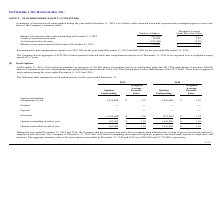According to Network 1 Technologies's financial document, Which note does the stockholders equity information belong to? According to the financial document, NOTE F. The relevant text states: "NOTE F – STOCKHOLDERS’ EQUITY (CONTINUED)..." Also, What does each restricted stock unit represent? each restricted stock unit represents the contingent right to receive one share of the Company’s common stock. The document states: "g the year ended December 31, 2019 is as follows (each restricted stock unit represents the contingent right to receive one share of the Company’s com..." Also, How many years are the unrecognized restricted stock unit compensation expensed over? According to the financial document, 1.2. The relevant text states: "to be expensed over a weighted average period of 1.2 years...." Also, can you calculate: What was the total restricted stock unit compensation expense for the years 2018 and 2019? Based on the calculation: 567,000 + 687,000  , the result is 1254000. This is based on the information: "567,000 for the year ended December 31, 2019 and $687,000 for the year ended December 31, 2018. Restricted stock unit compensation expense was $567,000 for the year ended December 31, 2019 and $687,00..." The key data points involved are: 567,000, 687,000. Also, can you calculate: What was the percentage change in balance of restricted stock units outstanding from 2018 to 2019? To answer this question, I need to perform calculations using the financial data. The calculation is: (340,000 - 505,000) / 505,000 , which equals -32.67 (percentage). This is based on the information: "ested restricted stock units at December 31, 2019 340,000 $ 2.15 cted stock units outstanding at December 31, 2018 505,000 $ 2.17..." The key data points involved are: 340,000, 505,000. Also, can you calculate: What is the difference in weighted-average grant date fair value for grants of restricted stock units and vested restricted stock units? Based on the calculation: 2.45 - (-2.29) , the result is 4.74. This is based on the information: "Grants of restricted stock units 70,000 2.45 Vested restricted stock units (235,000) (2.29)..." The key data points involved are: 2.29, 2.45. 